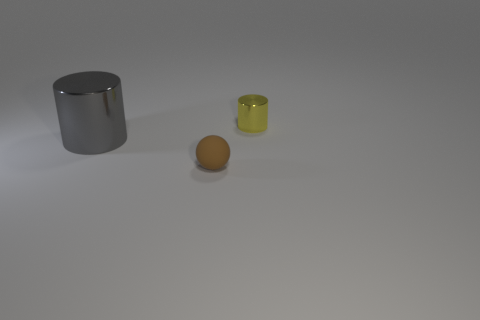Add 2 brown matte things. How many objects exist? 5 Subtract all cylinders. How many objects are left? 1 Subtract all yellow things. Subtract all brown matte balls. How many objects are left? 1 Add 3 cylinders. How many cylinders are left? 5 Add 3 tiny metallic things. How many tiny metallic things exist? 4 Subtract 0 blue spheres. How many objects are left? 3 